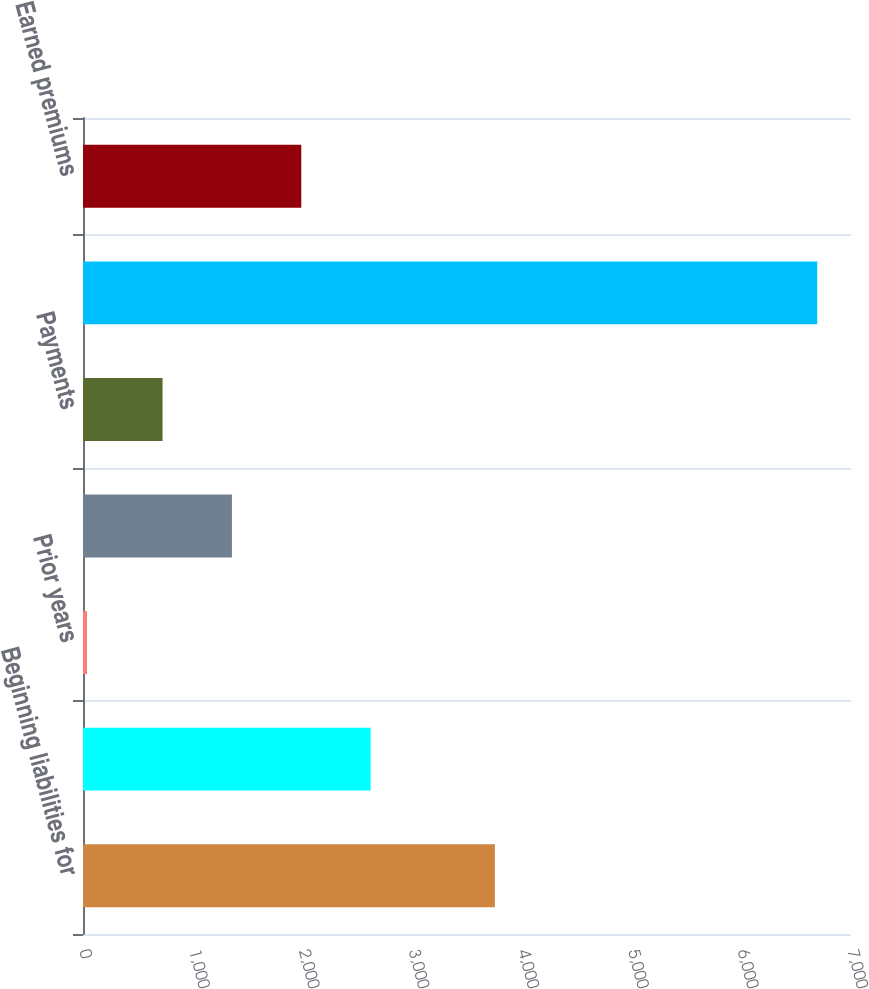Convert chart. <chart><loc_0><loc_0><loc_500><loc_500><bar_chart><fcel>Beginning liabilities for<fcel>Reinsurance and other<fcel>Prior years<fcel>Total provision for unpaid<fcel>Payments<fcel>Ending liabilities for unpaid<fcel>Earned premiums<nl><fcel>3754<fcel>2621.9<fcel>36<fcel>1357.3<fcel>725<fcel>6692.3<fcel>1989.6<nl></chart> 